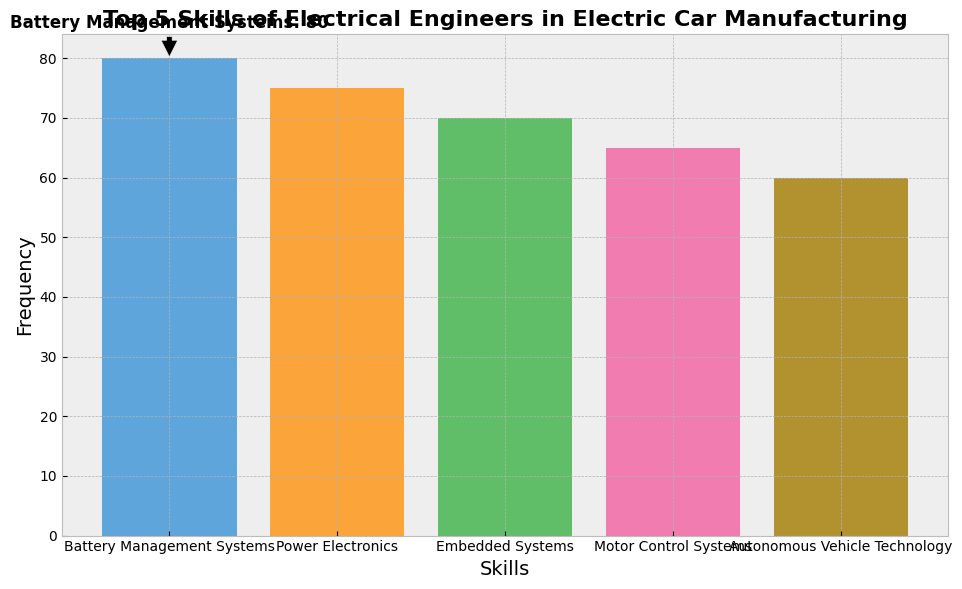What's the most frequently mentioned skill? The most frequently mentioned skill can be found by identifying the highest bar on the bar chart. Battery Management Systems has the highest bar with a frequency of 80.
Answer: Battery Management Systems Which skill has the smallest frequency? The skill with the smallest frequency is the one represented by the shortest bar on the chart. Autonomous Vehicle Technology has the shortest bar with a frequency of 60.
Answer: Autonomous Vehicle Technology How much higher is the frequency of Power Electronics compared to Motor Control Systems? First, identify the frequencies of Power Electronics and Motor Control Systems from the chart (75 and 65, respectively). Then, subtract the smaller frequency from the larger one: 75 - 65.
Answer: 10 What's the combined frequency of Battery Management Systems and Embedded Systems? Add the frequencies of Battery Management Systems and Embedded Systems from the chart. Battery Management Systems has a frequency of 80, and Embedded Systems has a frequency of 70. The combined frequency is 80 + 70.
Answer: 150 Which skill is in the middle when the skills are ranked by frequency? When ordered by frequency, the skills from highest to lowest are: Battery Management Systems (80), Power Electronics (75), Embedded Systems (70), Motor Control Systems (65), and Autonomous Vehicle Technology (60). The middle skill is Embedded Systems.
Answer: Embedded Systems How many skills have a frequency greater than 65? Identify the skills with frequencies greater than 65 by examining the bar chart. Battery Management Systems, Power Electronics, and Embedded Systems have frequencies of 80, 75, and 70, respectively. This gives 3 skills.
Answer: 3 Compare the frequencies of the skills represented by the blue and pink bars. Which one is higher? First, identify the colors of the bars and their corresponding skills, then compare their frequencies. The blue bar represents Battery Management Systems with a frequency of 80, and the pink bar represents Motor Control Systems with a frequency of 65. The blue bar is higher.
Answer: Blue (Battery Management Systems) What's the average frequency of the top three skills? Identify the top three skills by frequency: Battery Management Systems (80), Power Electronics (75), and Embedded Systems (70). Add their frequencies together and divide by 3: (80 + 75 + 70) / 3.
Answer: 75 What does the annotation on the chart indicate? The annotation on the chart highlights the skill with the highest frequency and its corresponding value. It points to Battery Management Systems with a frequency of 80.
Answer: Battery Management Systems: 80 Is the frequency of Autonomous Vehicle Technology more than 70% of that of Battery Management Systems? Calculate 70% of Battery Management Systems' frequency: 0.7 * 80 = 56. Compare this value with the frequency of Autonomous Vehicle Technology, which is 60. Since 60 is greater than 56, the answer is yes.
Answer: Yes 